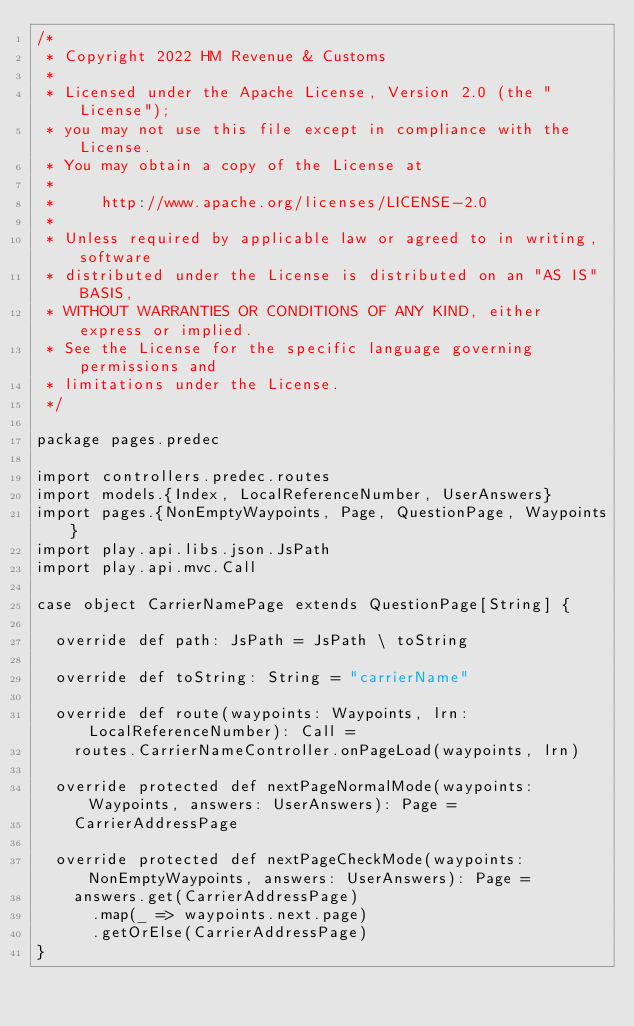<code> <loc_0><loc_0><loc_500><loc_500><_Scala_>/*
 * Copyright 2022 HM Revenue & Customs
 *
 * Licensed under the Apache License, Version 2.0 (the "License");
 * you may not use this file except in compliance with the License.
 * You may obtain a copy of the License at
 *
 *     http://www.apache.org/licenses/LICENSE-2.0
 *
 * Unless required by applicable law or agreed to in writing, software
 * distributed under the License is distributed on an "AS IS" BASIS,
 * WITHOUT WARRANTIES OR CONDITIONS OF ANY KIND, either express or implied.
 * See the License for the specific language governing permissions and
 * limitations under the License.
 */

package pages.predec

import controllers.predec.routes
import models.{Index, LocalReferenceNumber, UserAnswers}
import pages.{NonEmptyWaypoints, Page, QuestionPage, Waypoints}
import play.api.libs.json.JsPath
import play.api.mvc.Call

case object CarrierNamePage extends QuestionPage[String] {

  override def path: JsPath = JsPath \ toString

  override def toString: String = "carrierName"

  override def route(waypoints: Waypoints, lrn: LocalReferenceNumber): Call =
    routes.CarrierNameController.onPageLoad(waypoints, lrn)

  override protected def nextPageNormalMode(waypoints: Waypoints, answers: UserAnswers): Page =
    CarrierAddressPage

  override protected def nextPageCheckMode(waypoints: NonEmptyWaypoints, answers: UserAnswers): Page =
    answers.get(CarrierAddressPage)
      .map(_ => waypoints.next.page)
      .getOrElse(CarrierAddressPage)
}
</code> 